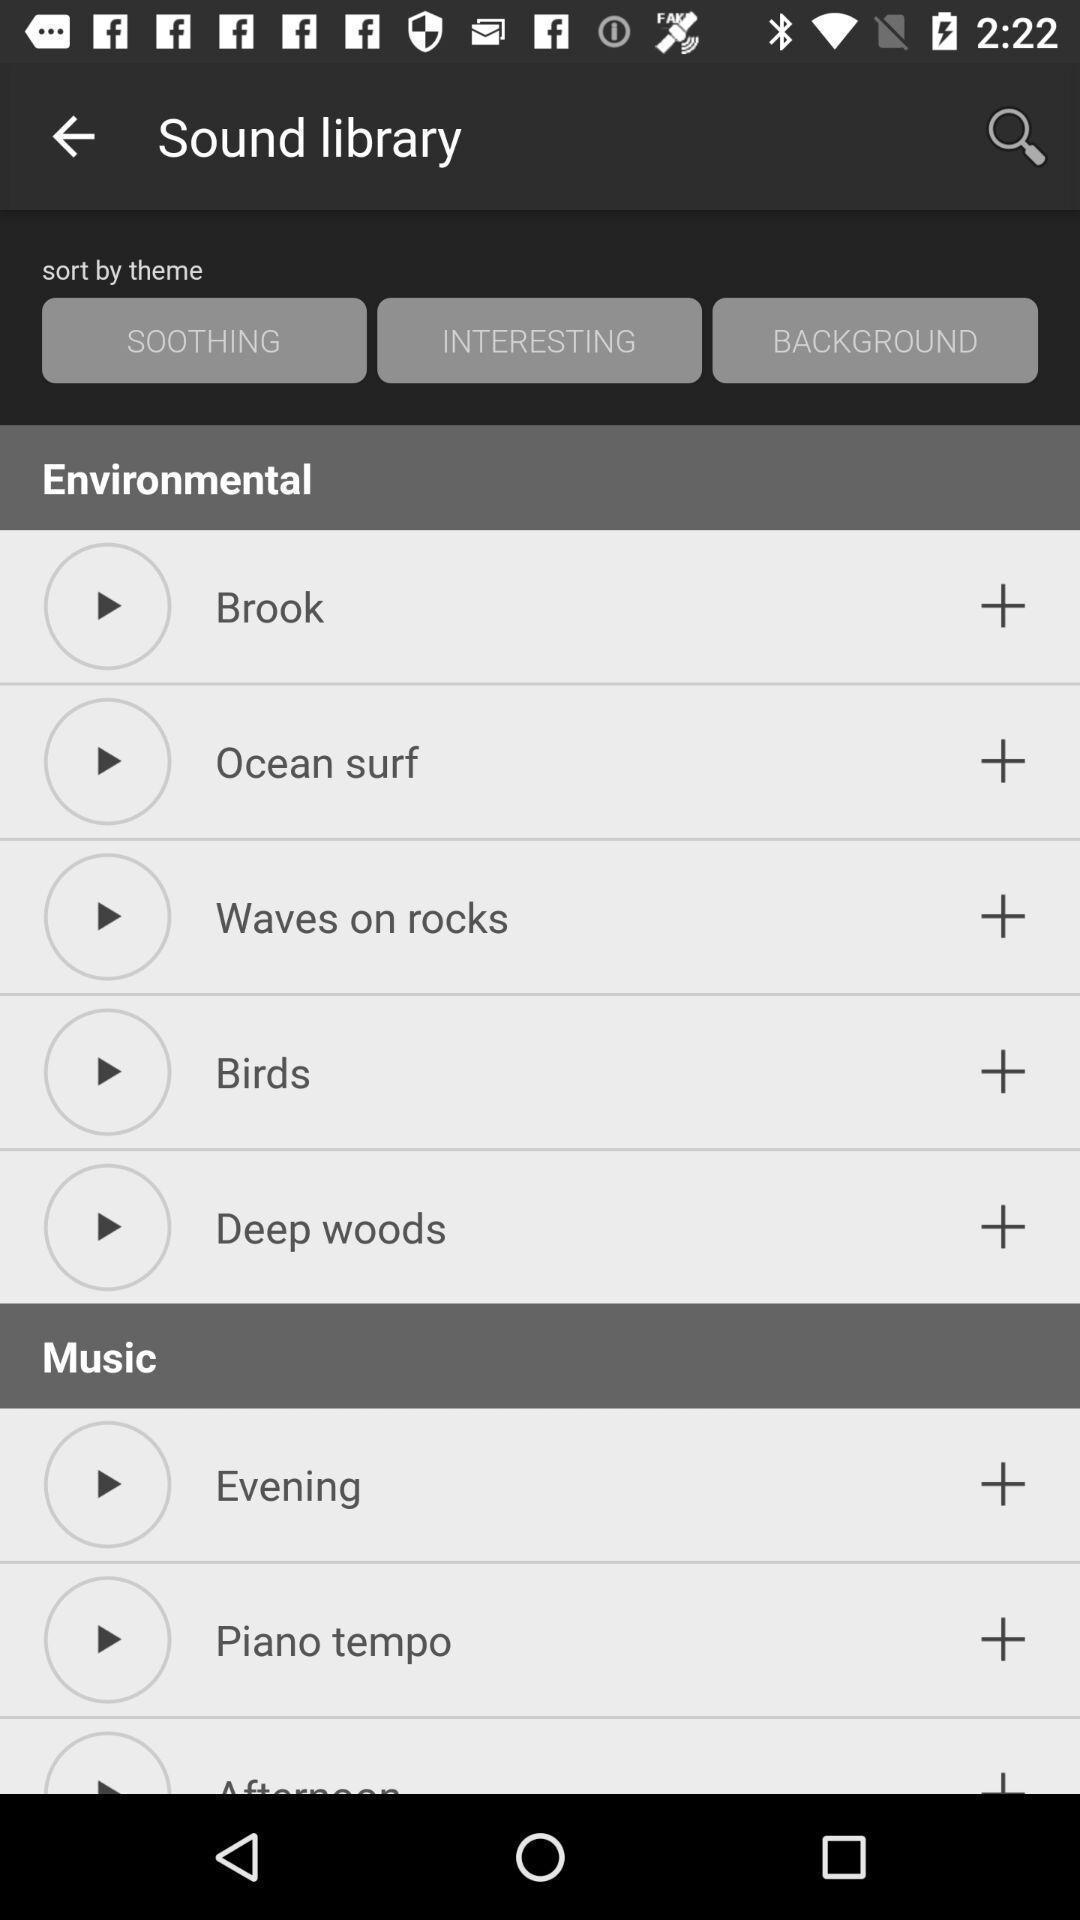What details can you identify in this image? Screen shows list of songs in music app. 